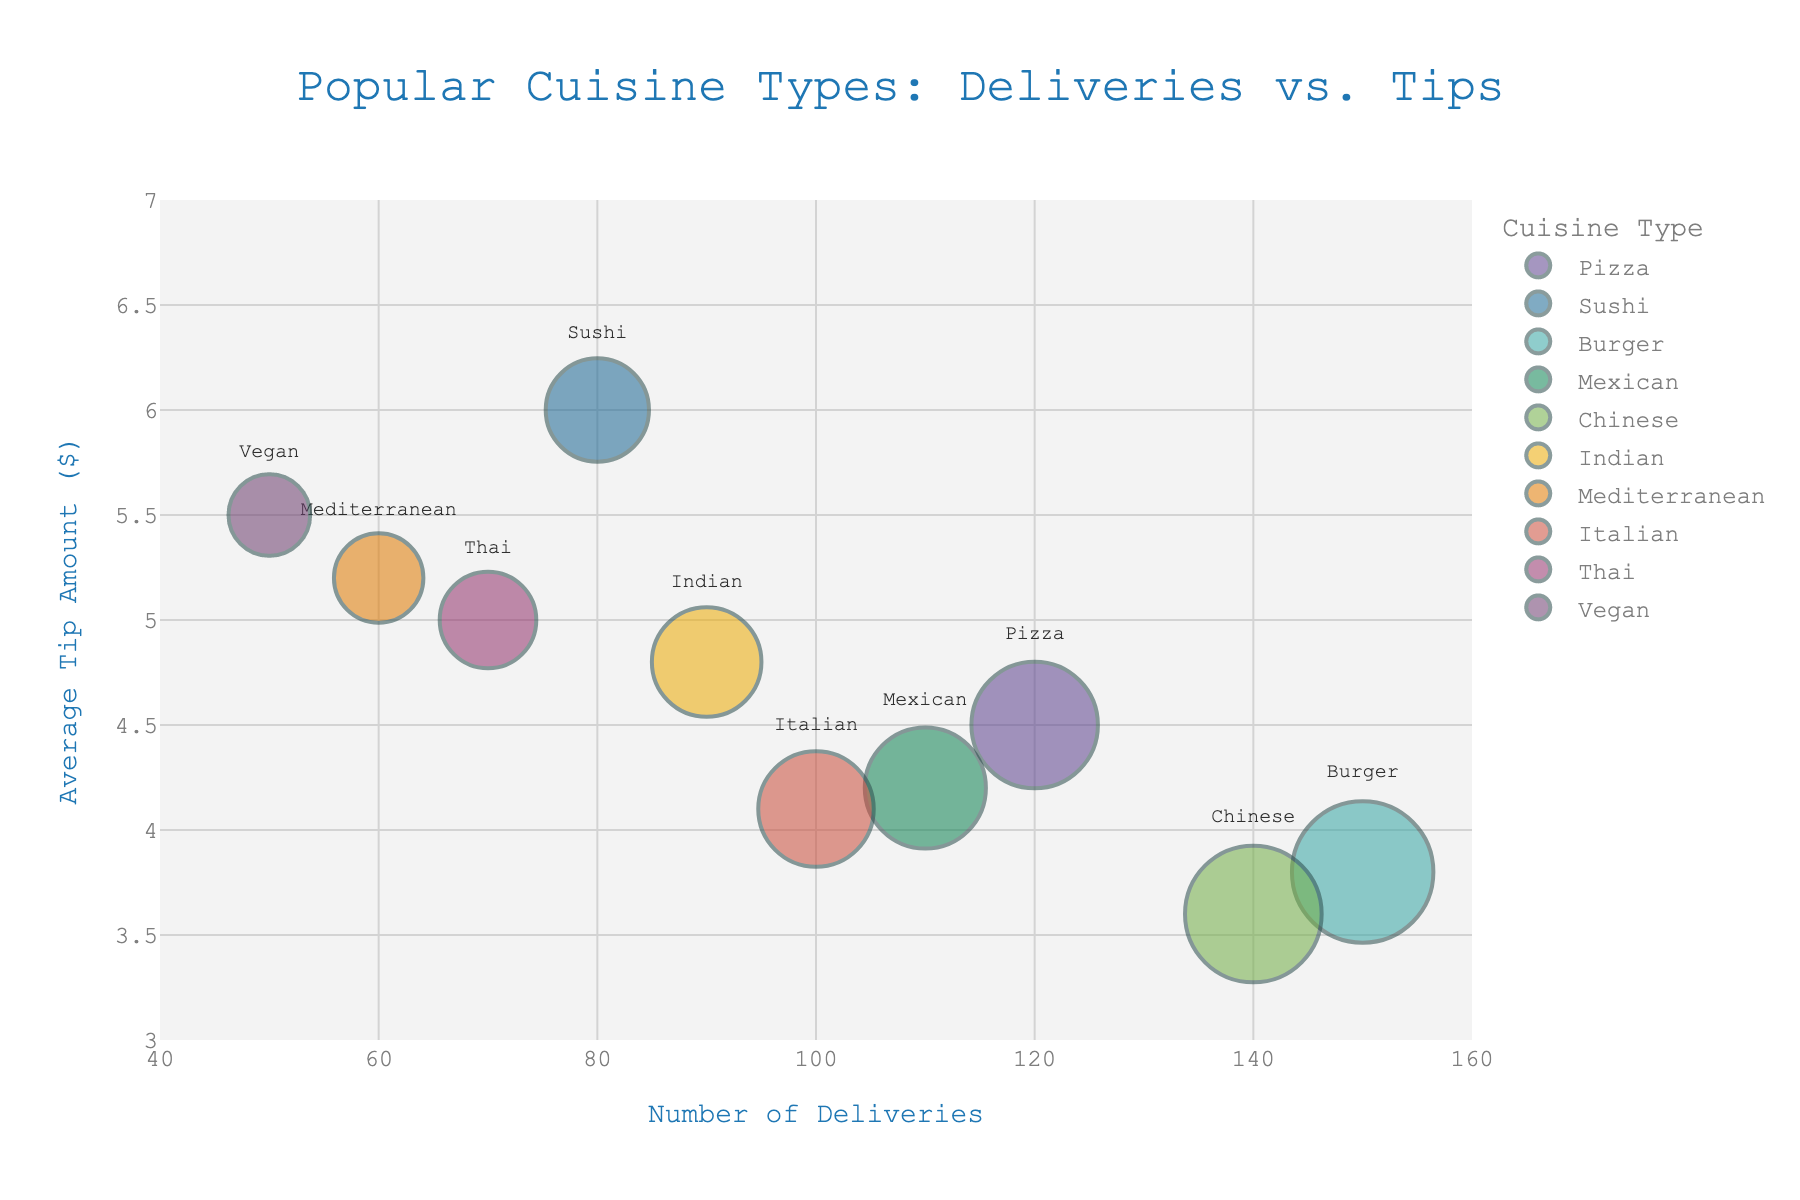what is the title of the chart? The title is displayed at the top of the chart, generally in larger and bold font to differentiate it from other text. It serves as an introduction to the chart and provides context.
Answer: Popular Cuisine Types: Deliveries vs. Tips how many cuisine types are represented on the chart? By looking at the different colors and labels for each data point on the chart, we can count the number of unique cuisine types. Each cuisine type is represented by a different color and label.
Answer: 10 which cuisine type has the highest average tip amount? The Average Tip Amount is plotted on the y-axis. We can identify the cuisine type with the highest average tip by locating the highest data point on the y-axis.
Answer: Sushi what is the number of deliveries for Indian cuisine? Look for the bubble labeled "Indian" and check its position along the x-axis, which represents the Number of Deliveries.
Answer: 90 which cuisine type has both a high number of deliveries and a relatively low average tip amount? To answer this, look for cuisine types with large bubbles (indicating high number of deliveries) placed lower on the y-axis (indicating lower average tip amount).
Answer: Burger what is the average tip amount for Mediterranean cuisine? Look at the bubble labeled "Mediterranean" and check its position along the y-axis, which represents the Average Tip Amount.
Answer: 5.2 how many cuisine types have an average tip of more than $5.0? Locate all the bubbles positioned above the $5.0 mark on the y-axis and count the unique cuisine types they represent.
Answer: 4 compare the number of deliveries between Pizza and Chinese cuisine. Which has more? Look at the positions of the bubbles labeled "Pizza" and "Chinese" on the x-axis (Number of Deliveries) and compare their values.
Answer: Burger which cuisine type has the smallest bubble, and what does it represent? The size of the bubble is relative to the Number of Deliveries. Look for the smallest bubble on the chart and identify its label.
Answer: Vegan what is the difference in the average tip amount between Thai and Mexican cuisine? Locate the bubbles for "Thai" and "Mexican" cuisine on the y-axis and subtract the Average Tip Amount of Mexican from that of Thai.
Answer: 0.8 